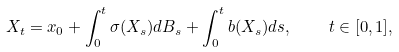<formula> <loc_0><loc_0><loc_500><loc_500>X _ { t } = x _ { 0 } + \int _ { 0 } ^ { t } \sigma ( X _ { s } ) d B _ { s } + \int _ { 0 } ^ { t } b ( X _ { s } ) d s , \quad t \in [ 0 , 1 ] ,</formula> 